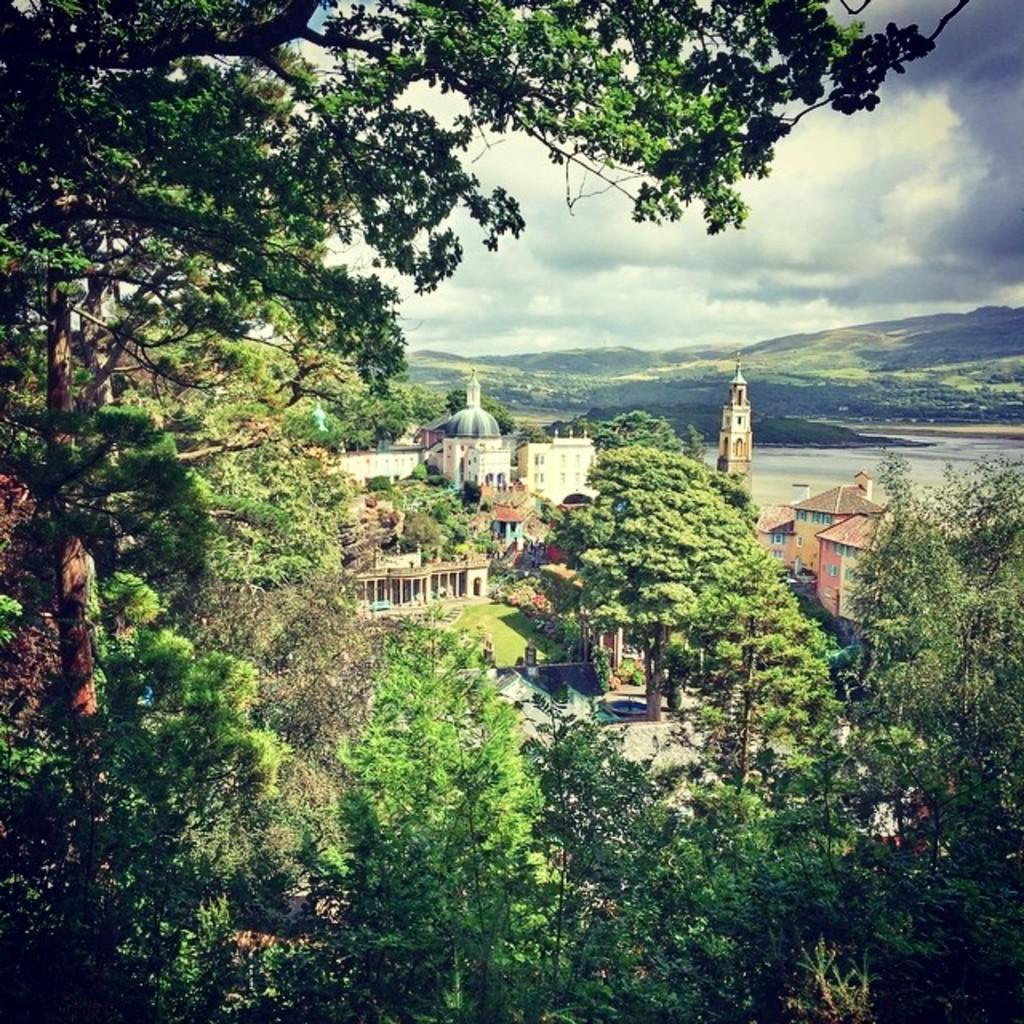In one or two sentences, can you explain what this image depicts? In this image in the foreground there are trees, and in the center of the image there are buildings and trees and there is a walkway. In the background there is a river and mountains, at the top there is sky. 